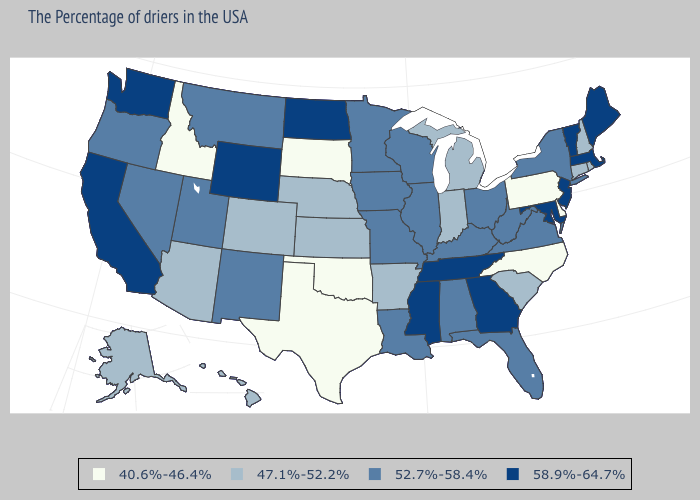Does Idaho have the lowest value in the West?
Quick response, please. Yes. Among the states that border Nebraska , does South Dakota have the lowest value?
Be succinct. Yes. What is the value of Nebraska?
Short answer required. 47.1%-52.2%. Among the states that border Indiana , does Michigan have the highest value?
Short answer required. No. Does Maine have the same value as Mississippi?
Quick response, please. Yes. Name the states that have a value in the range 52.7%-58.4%?
Concise answer only. New York, Virginia, West Virginia, Ohio, Florida, Kentucky, Alabama, Wisconsin, Illinois, Louisiana, Missouri, Minnesota, Iowa, New Mexico, Utah, Montana, Nevada, Oregon. Is the legend a continuous bar?
Write a very short answer. No. Name the states that have a value in the range 52.7%-58.4%?
Keep it brief. New York, Virginia, West Virginia, Ohio, Florida, Kentucky, Alabama, Wisconsin, Illinois, Louisiana, Missouri, Minnesota, Iowa, New Mexico, Utah, Montana, Nevada, Oregon. Name the states that have a value in the range 40.6%-46.4%?
Give a very brief answer. Delaware, Pennsylvania, North Carolina, Oklahoma, Texas, South Dakota, Idaho. What is the value of Indiana?
Short answer required. 47.1%-52.2%. What is the highest value in the USA?
Keep it brief. 58.9%-64.7%. Does South Carolina have the highest value in the South?
Give a very brief answer. No. Which states have the lowest value in the South?
Short answer required. Delaware, North Carolina, Oklahoma, Texas. Name the states that have a value in the range 52.7%-58.4%?
Answer briefly. New York, Virginia, West Virginia, Ohio, Florida, Kentucky, Alabama, Wisconsin, Illinois, Louisiana, Missouri, Minnesota, Iowa, New Mexico, Utah, Montana, Nevada, Oregon. 